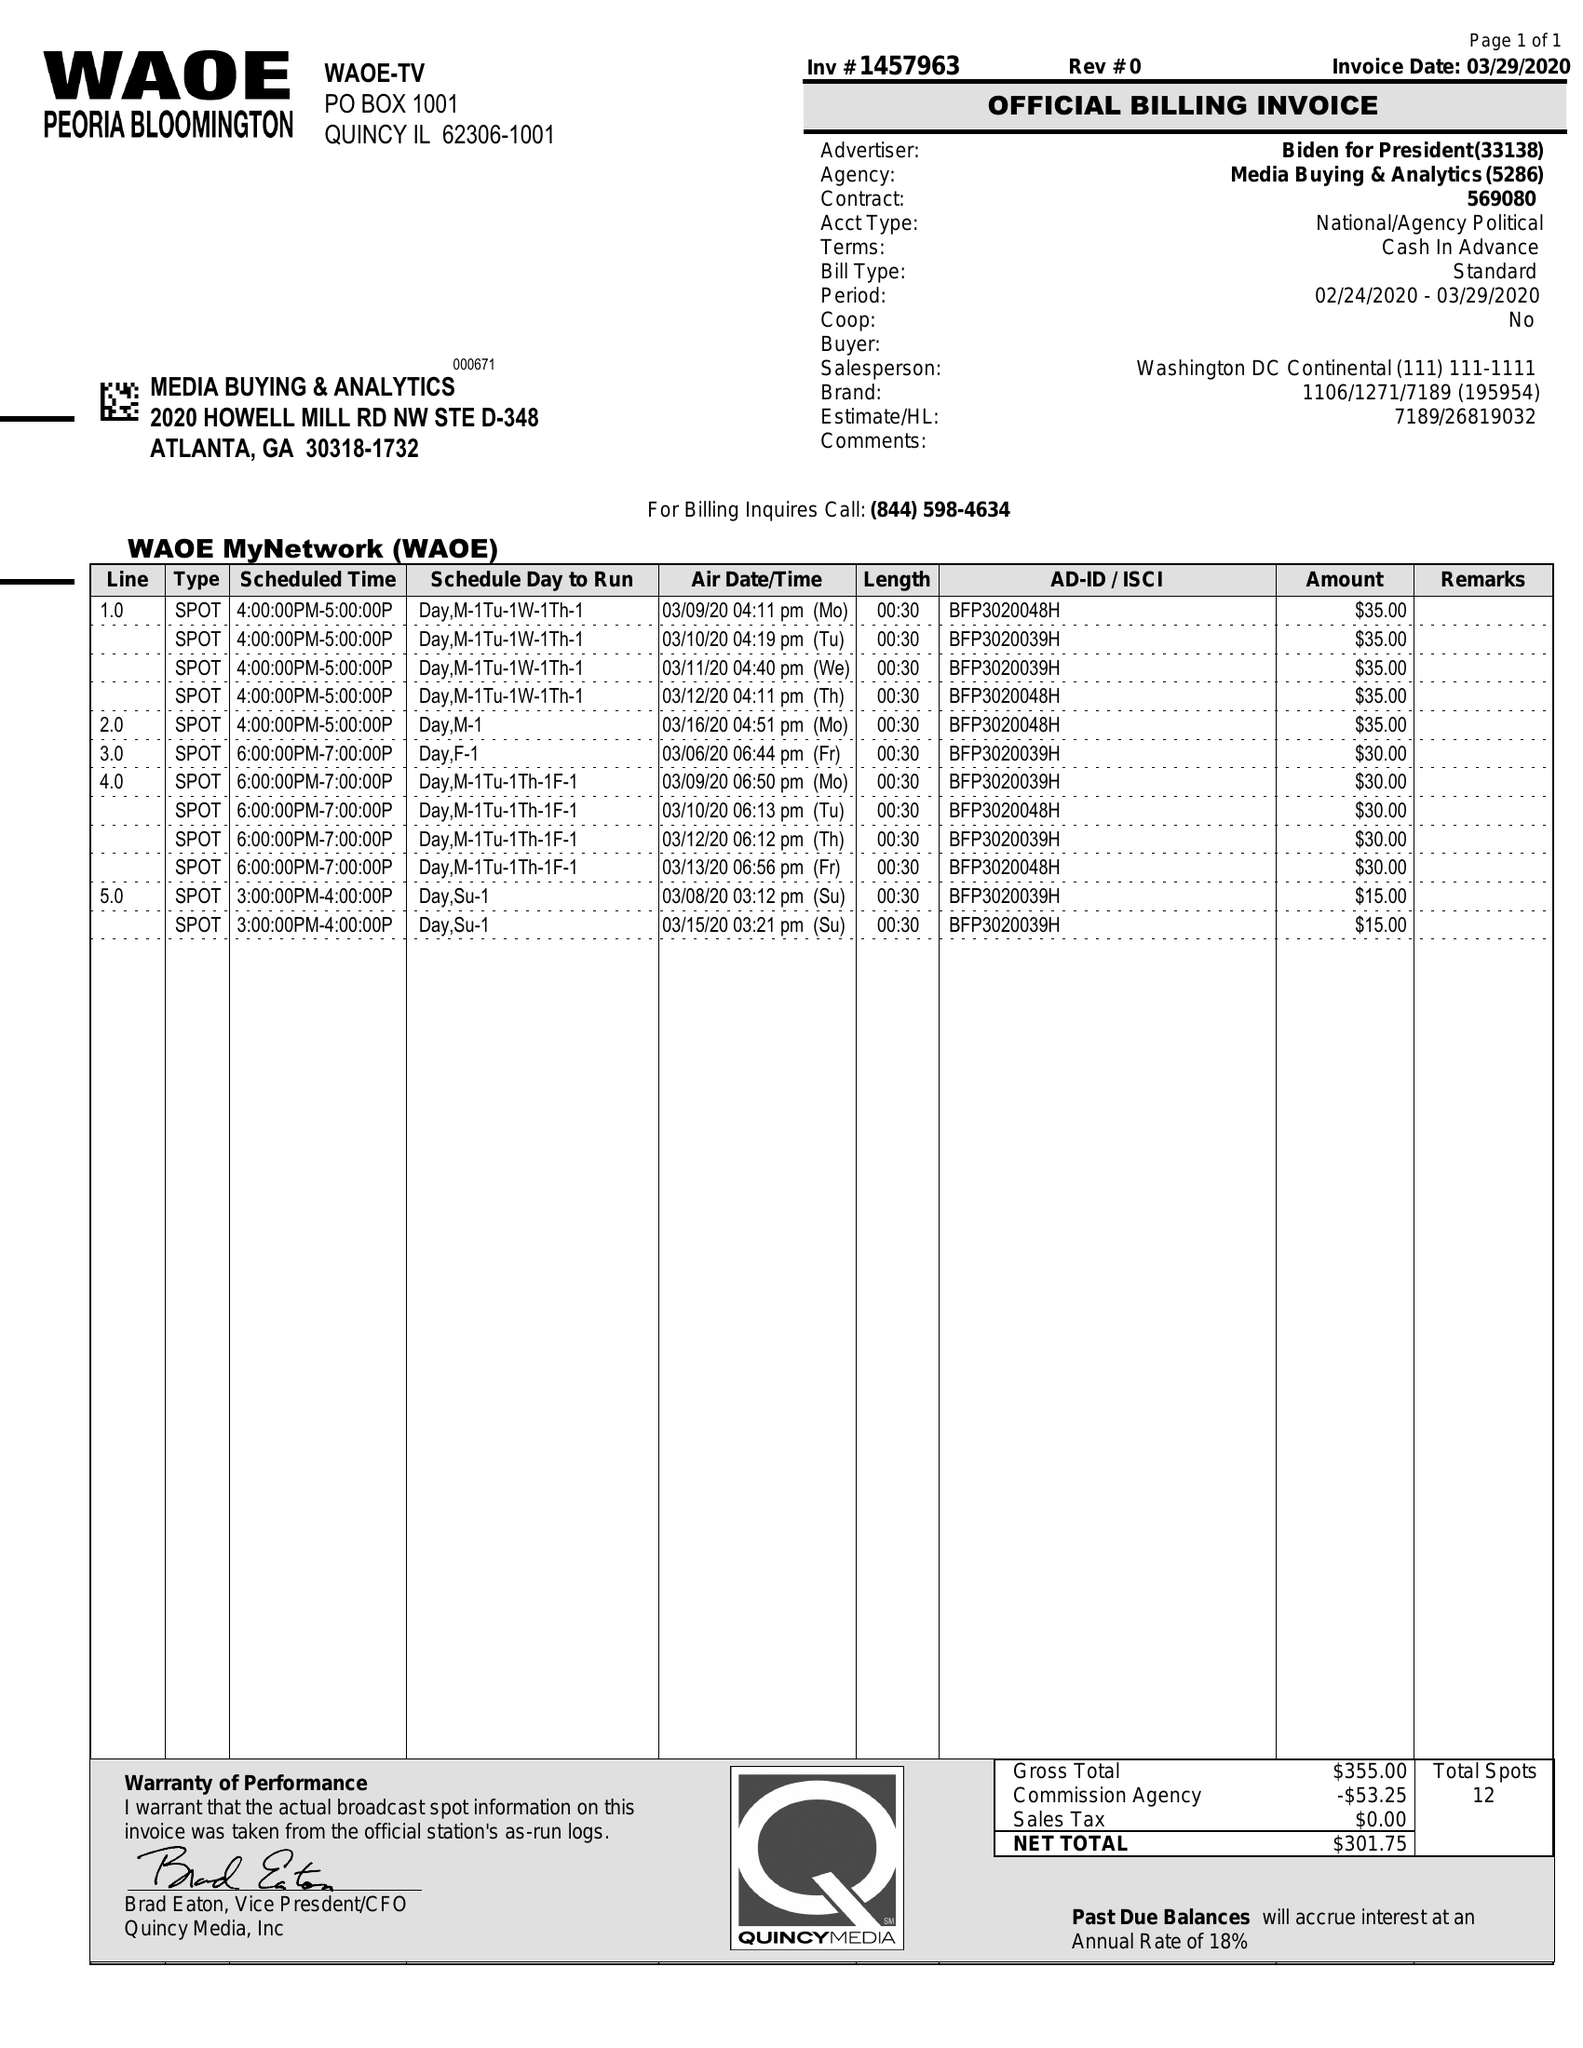What is the value for the flight_to?
Answer the question using a single word or phrase. 03/16/20 